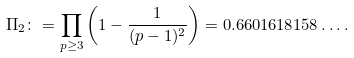Convert formula to latex. <formula><loc_0><loc_0><loc_500><loc_500>\Pi _ { 2 } \colon = \prod _ { p \geq 3 } \left ( 1 - { \frac { 1 } { ( p - 1 ) ^ { 2 } } } \right ) = 0 . 6 6 0 1 6 1 8 1 5 8 \dots .</formula> 